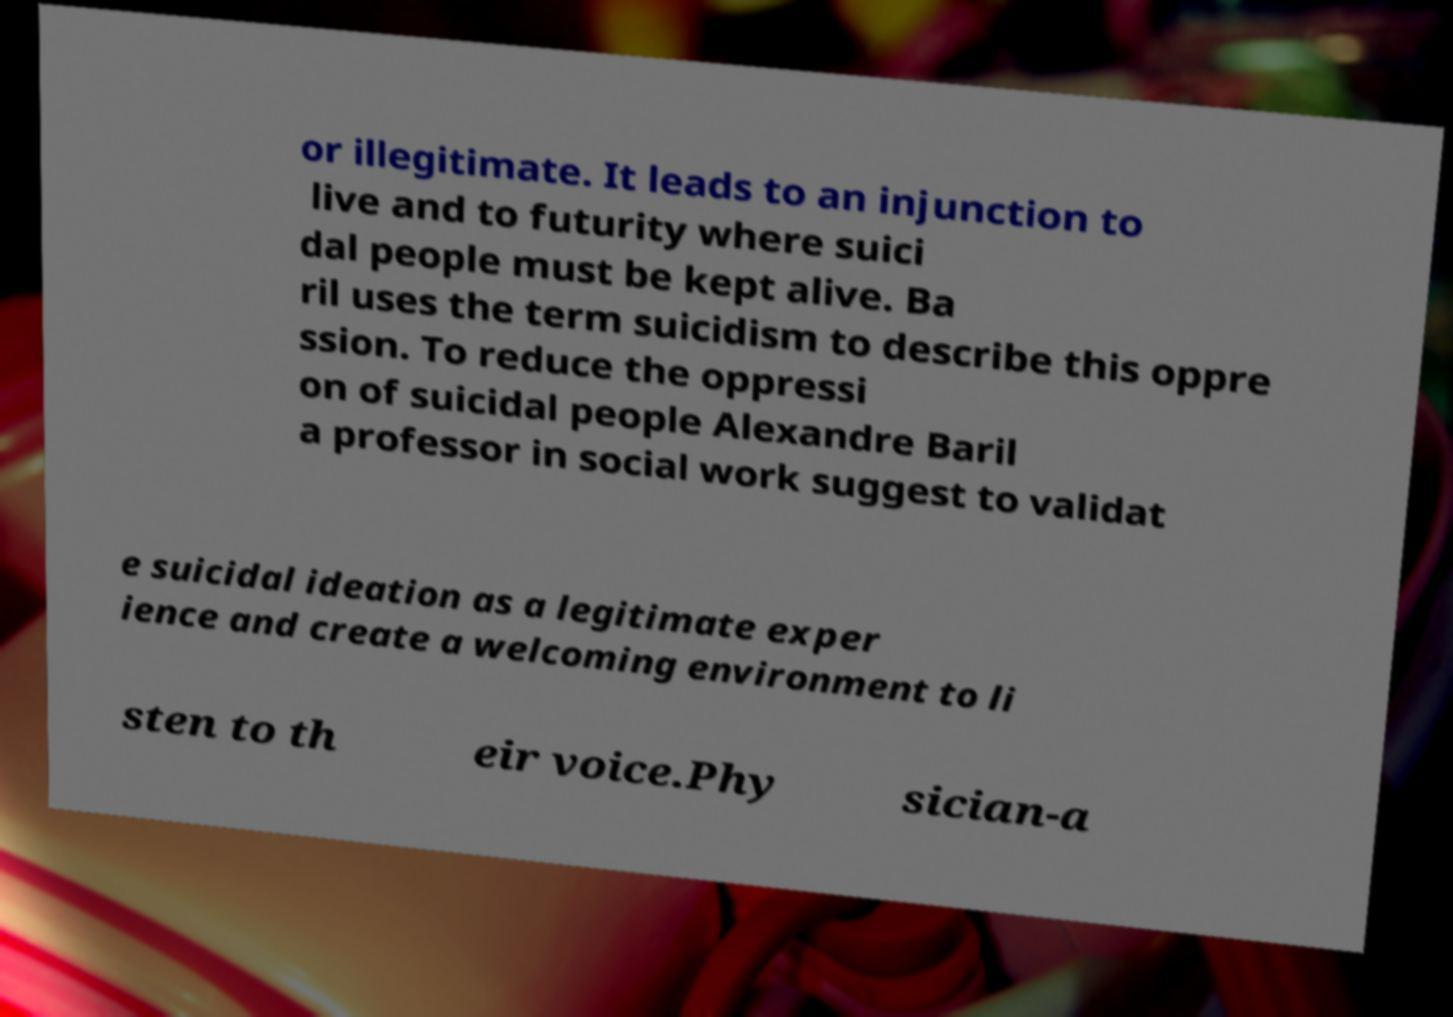Please read and relay the text visible in this image. What does it say? or illegitimate. It leads to an injunction to live and to futurity where suici dal people must be kept alive. Ba ril uses the term suicidism to describe this oppre ssion. To reduce the oppressi on of suicidal people Alexandre Baril a professor in social work suggest to validat e suicidal ideation as a legitimate exper ience and create a welcoming environment to li sten to th eir voice.Phy sician-a 